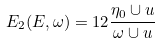<formula> <loc_0><loc_0><loc_500><loc_500>E _ { 2 } ( E , \omega ) = 1 2 \frac { \eta _ { 0 } \cup u } { \omega \cup u }</formula> 